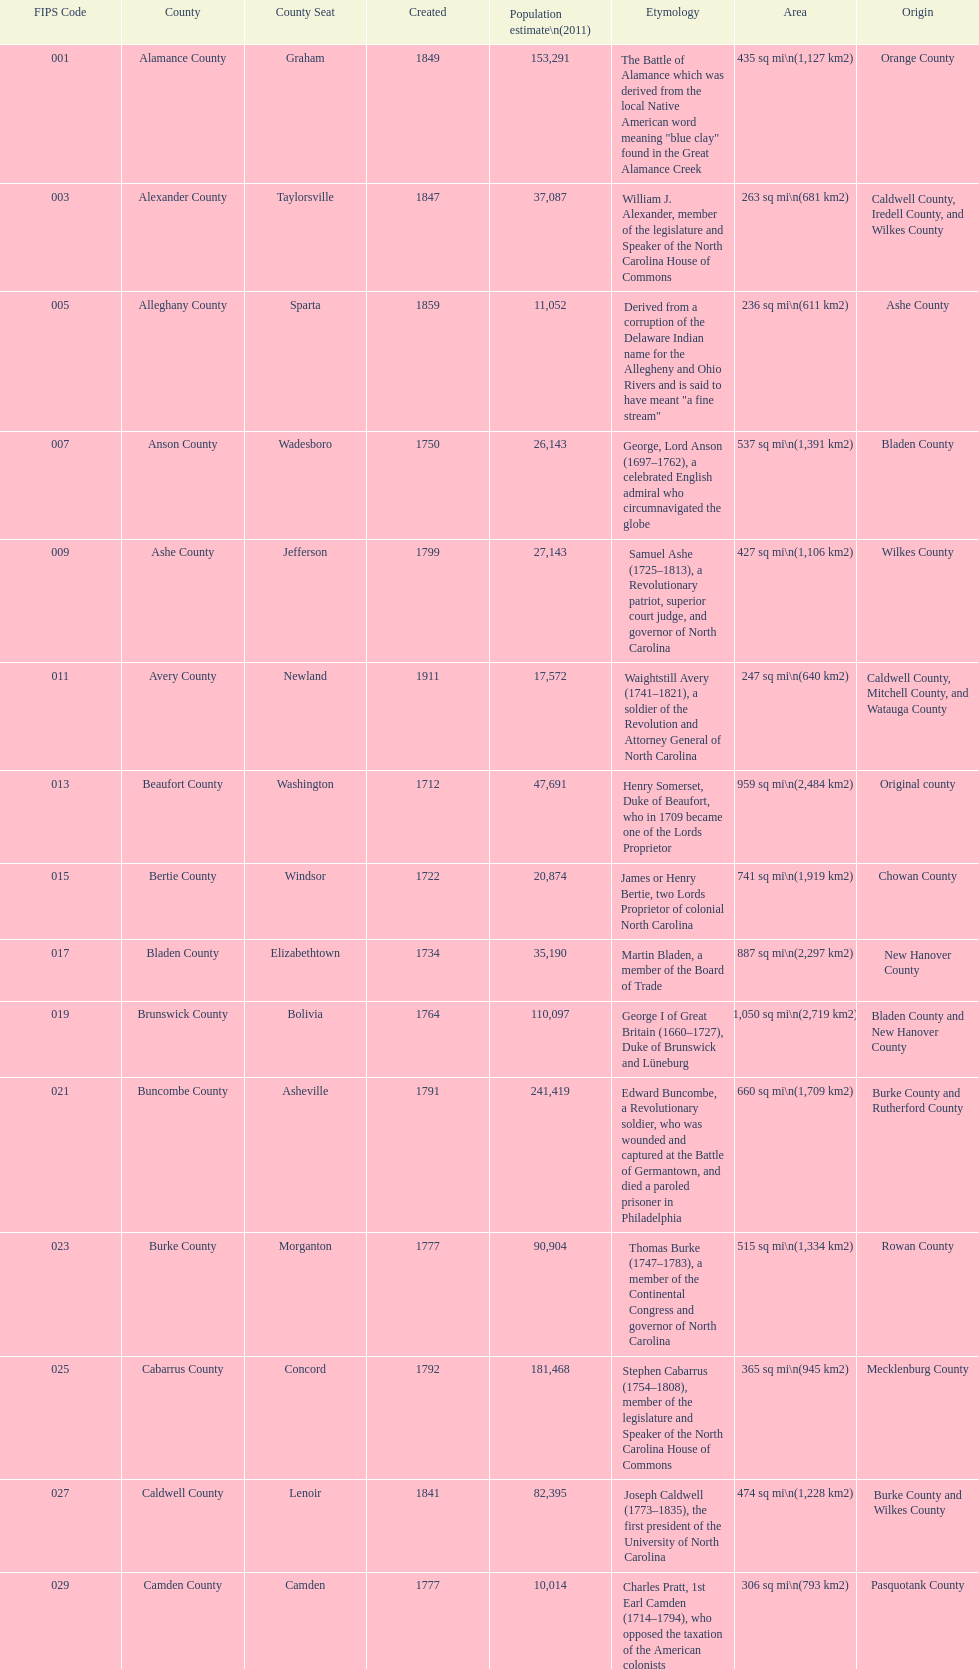What is the total number of counties listed? 100. 